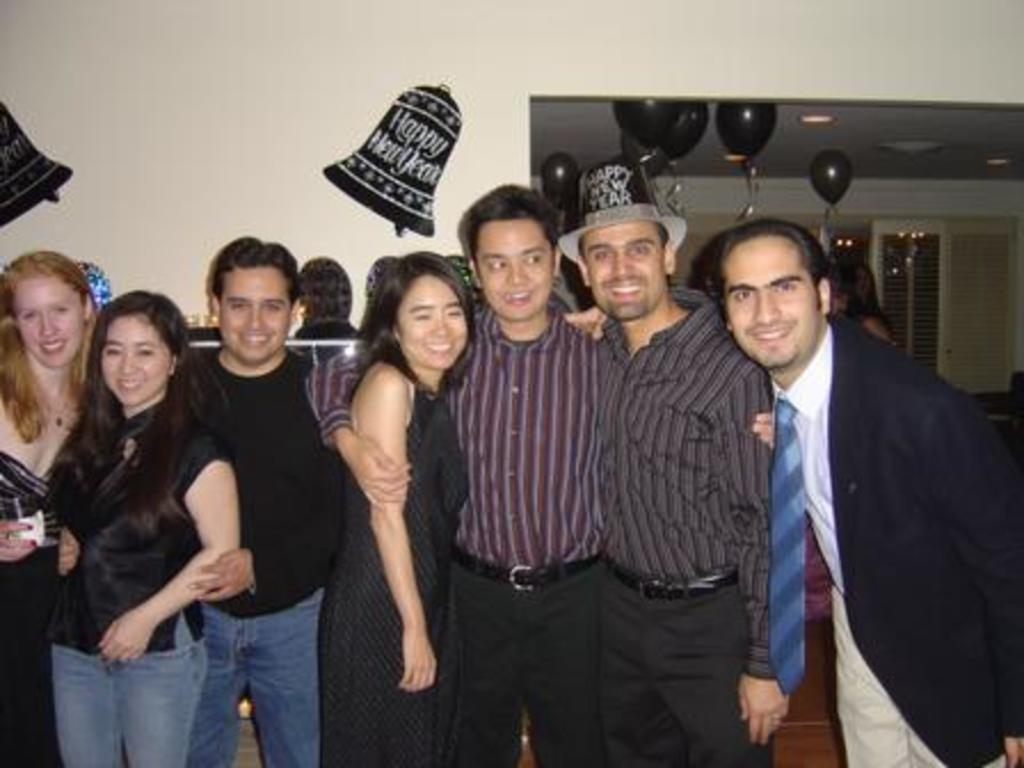Can you describe this image briefly? In the picture we can see some people are standing and holding each other and smiling, in the background, we can see a wall with some decoration and balloons which are black in color and near to it we can see a door with a glass to it. 